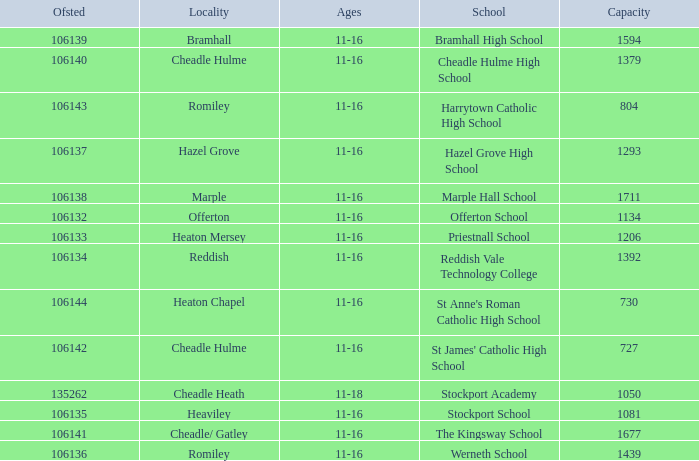Which School has a Capacity larger than 730, and an Ofsted smaller than 106135, and a Locality of heaton mersey? Priestnall School. 